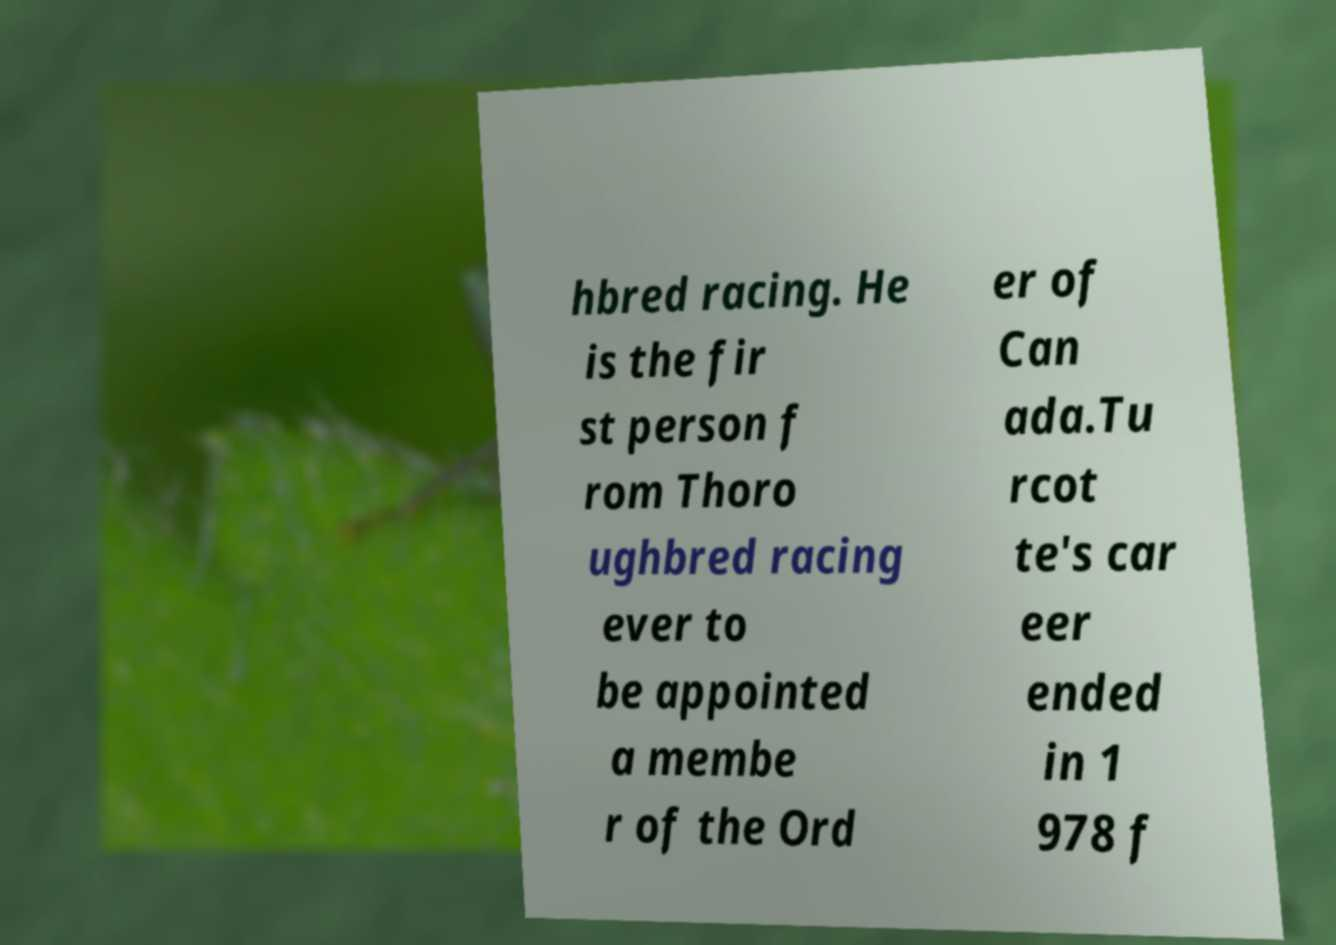There's text embedded in this image that I need extracted. Can you transcribe it verbatim? hbred racing. He is the fir st person f rom Thoro ughbred racing ever to be appointed a membe r of the Ord er of Can ada.Tu rcot te's car eer ended in 1 978 f 